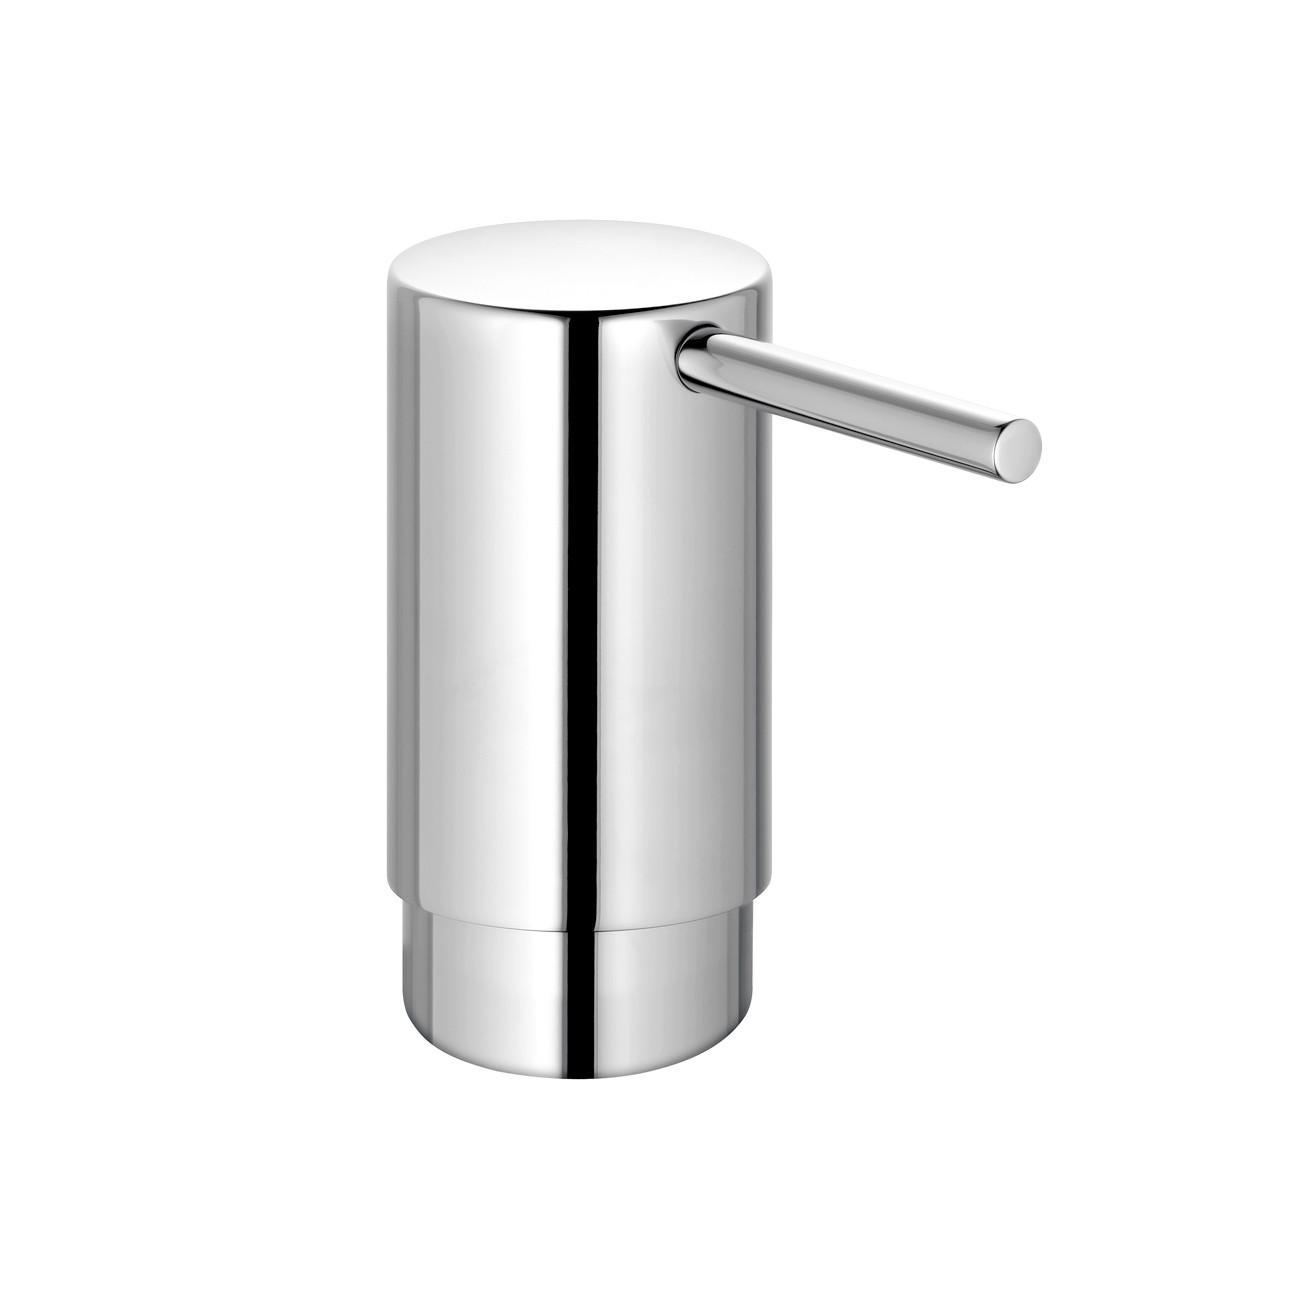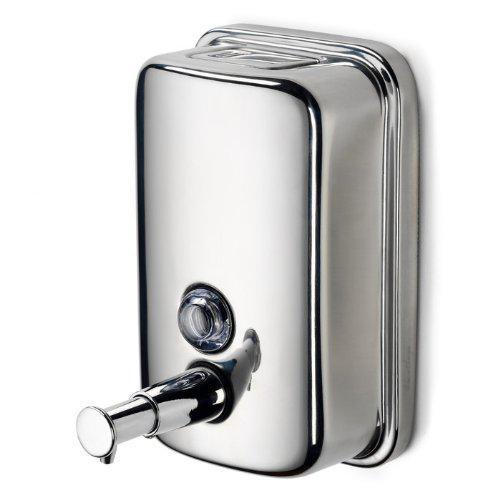The first image is the image on the left, the second image is the image on the right. For the images displayed, is the sentence "The two dispensers in the paired images appear to face toward each other." factually correct? Answer yes or no. Yes. 